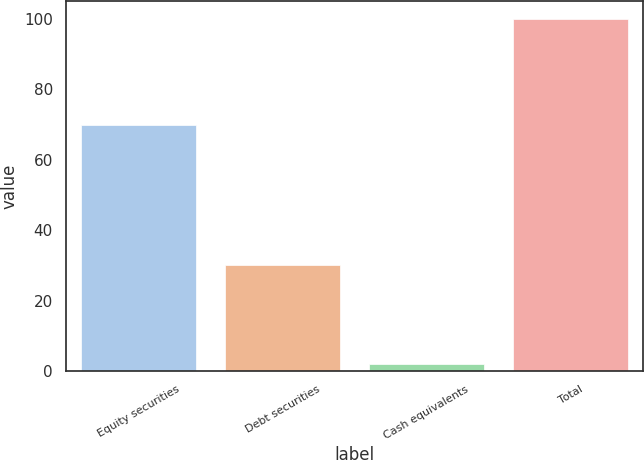Convert chart to OTSL. <chart><loc_0><loc_0><loc_500><loc_500><bar_chart><fcel>Equity securities<fcel>Debt securities<fcel>Cash equivalents<fcel>Total<nl><fcel>70<fcel>30<fcel>1.97<fcel>100<nl></chart> 